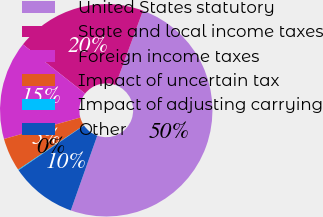Convert chart. <chart><loc_0><loc_0><loc_500><loc_500><pie_chart><fcel>United States statutory<fcel>State and local income taxes<fcel>Foreign income taxes<fcel>Impact of uncertain tax<fcel>Impact of adjusting carrying<fcel>Other<nl><fcel>49.79%<fcel>19.97%<fcel>15.01%<fcel>5.08%<fcel>0.11%<fcel>10.04%<nl></chart> 